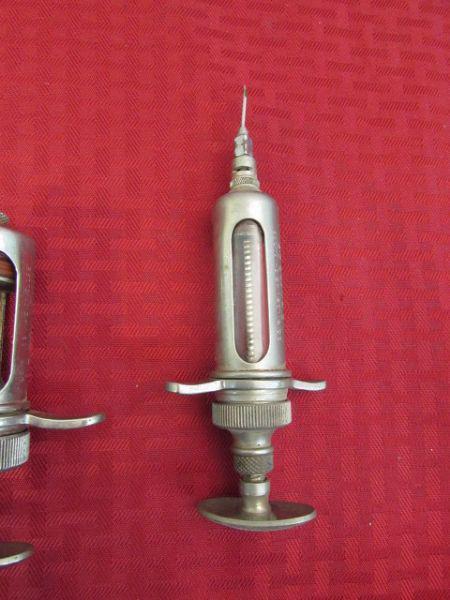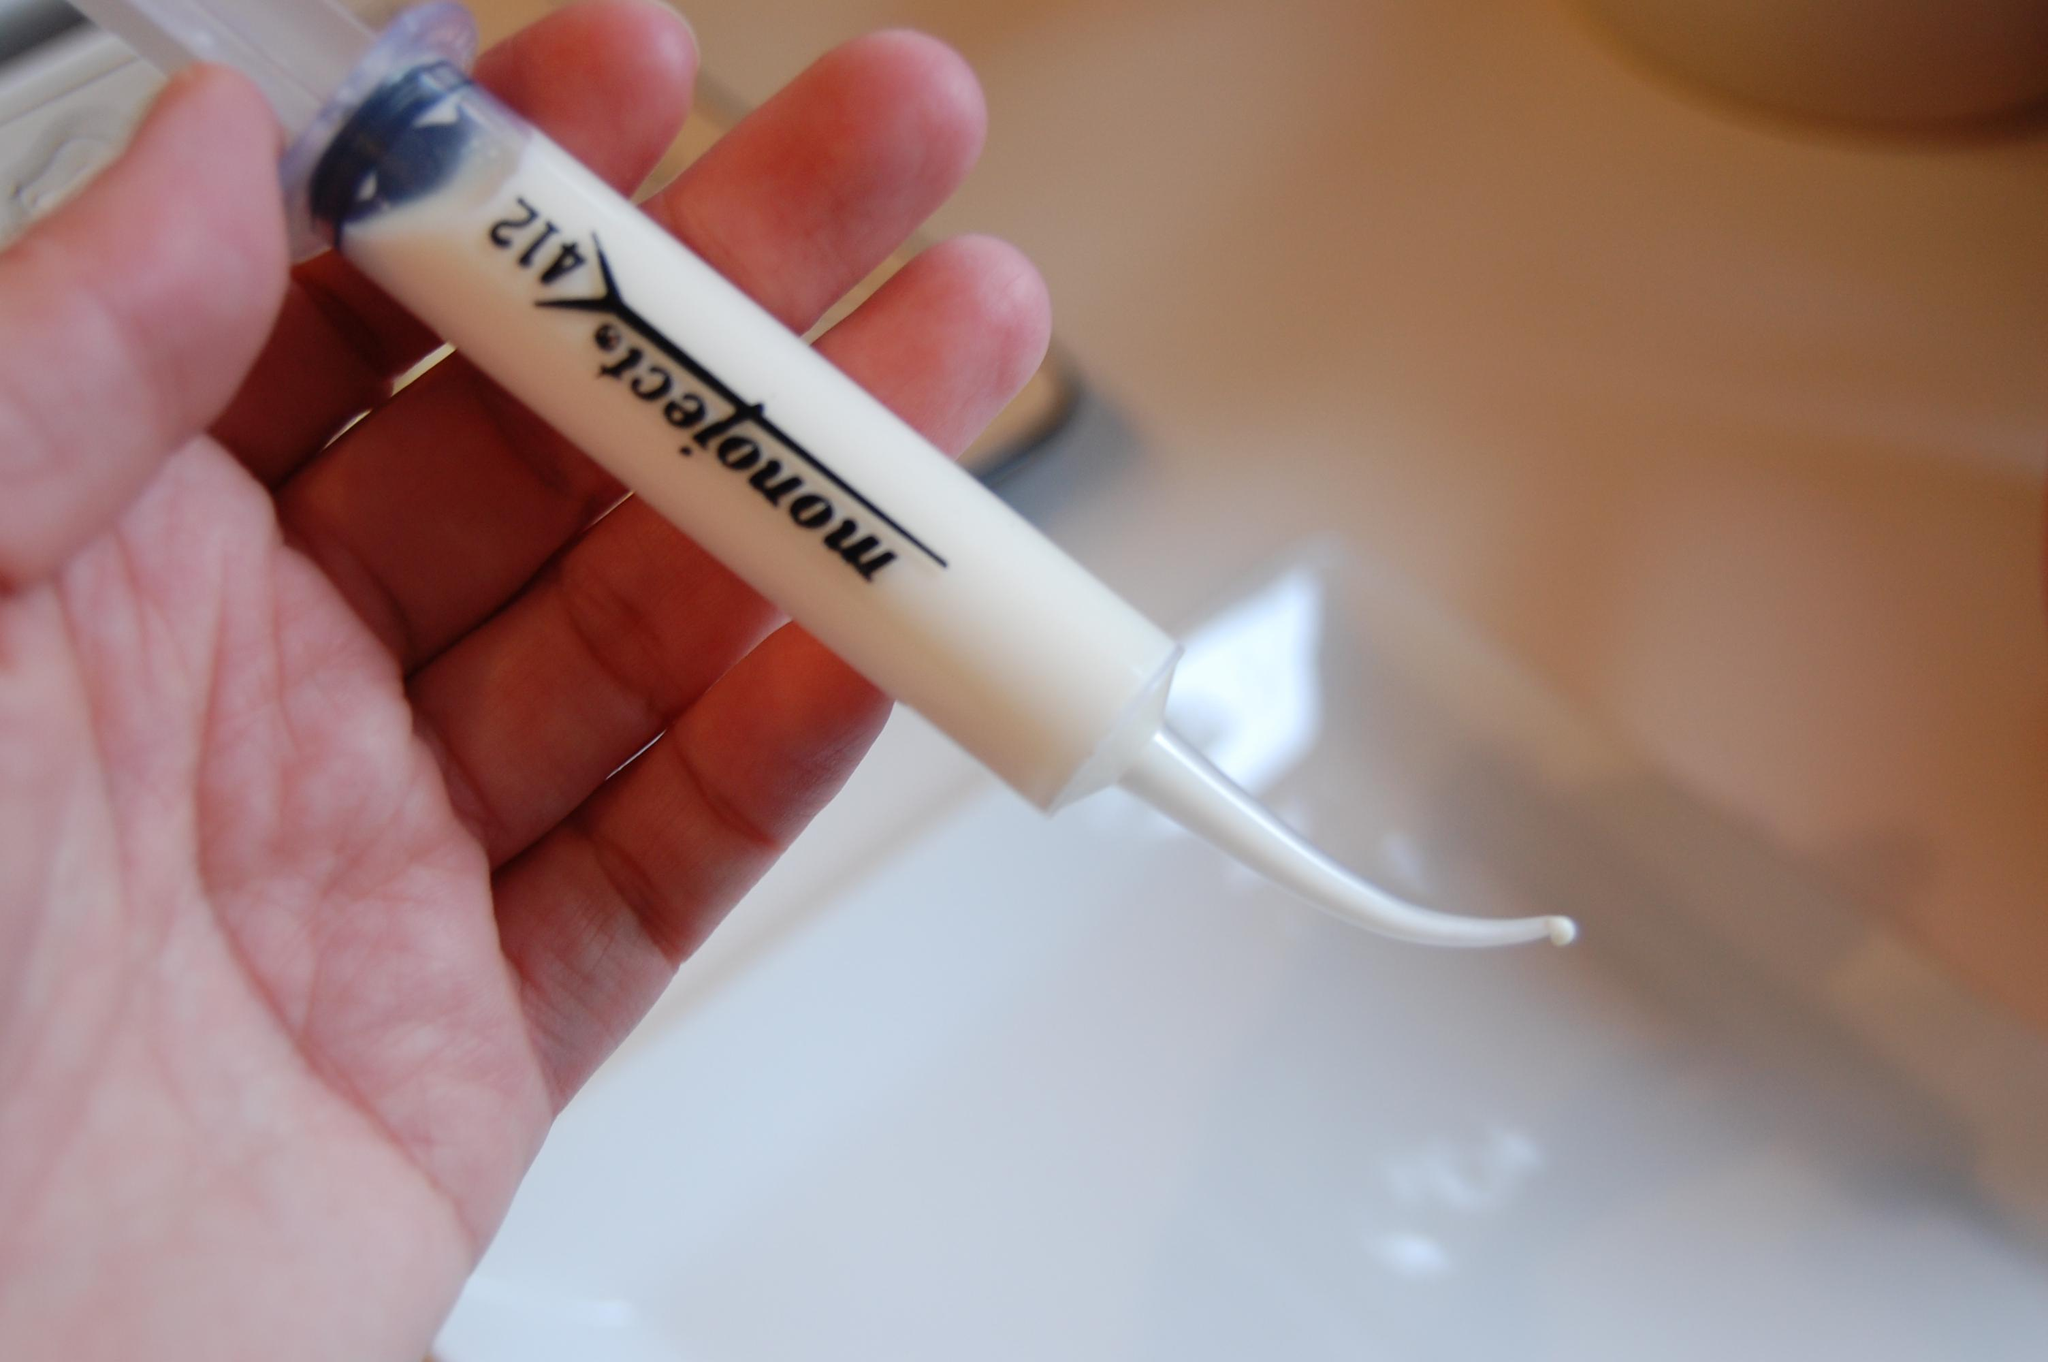The first image is the image on the left, the second image is the image on the right. Evaluate the accuracy of this statement regarding the images: "At least one syringe in the image on the left has a pink tip.". Is it true? Answer yes or no. No. The first image is the image on the left, the second image is the image on the right. Given the left and right images, does the statement "At least one image includes an all-metal syringe displayed on a red surface." hold true? Answer yes or no. Yes. 